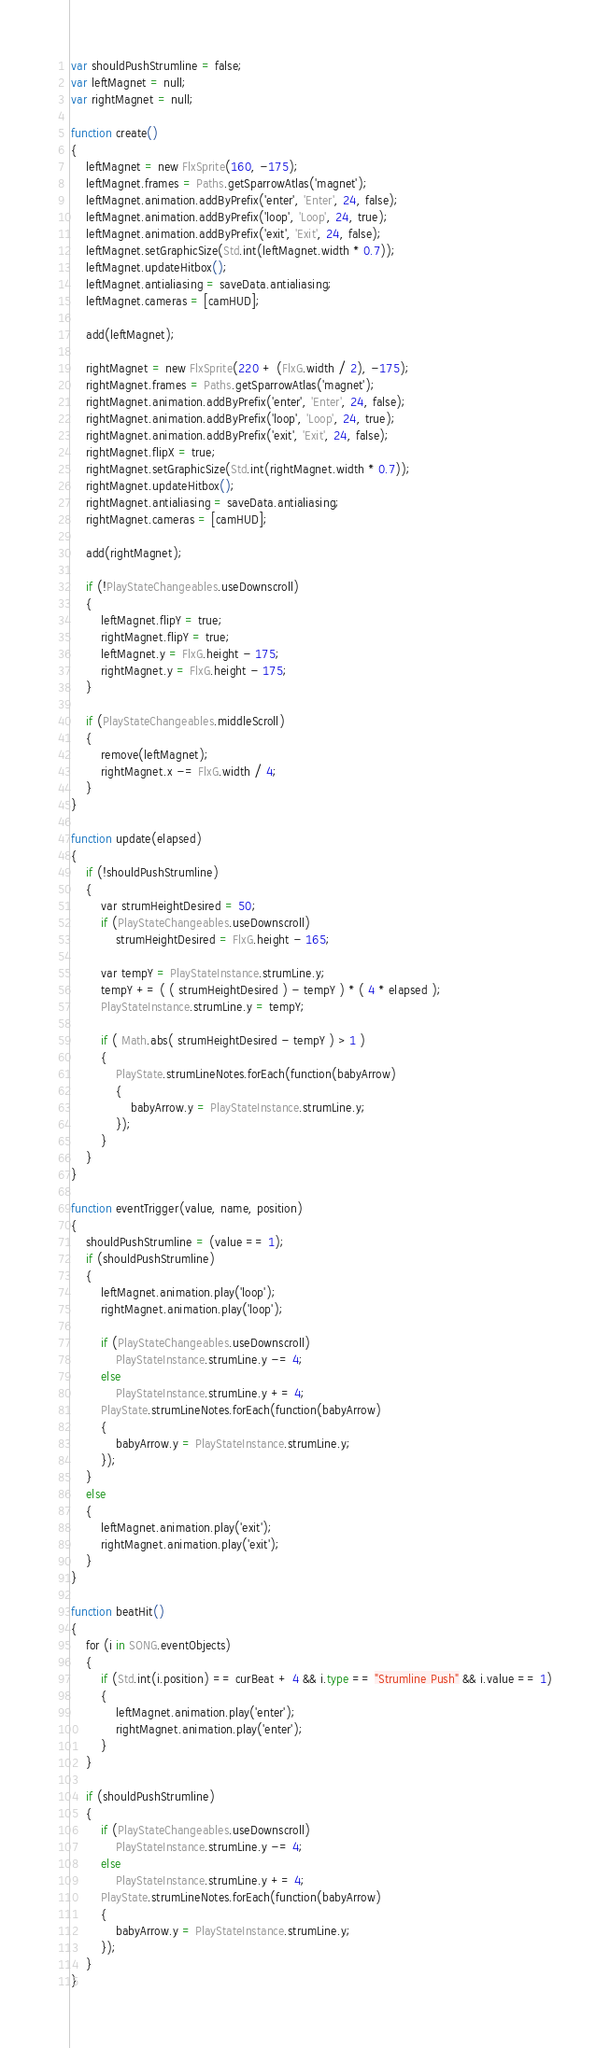Convert code to text. <code><loc_0><loc_0><loc_500><loc_500><_Haskell_>var shouldPushStrumline = false;
var leftMagnet = null;
var rightMagnet = null;

function create()
{
	leftMagnet = new FlxSprite(160, -175);
	leftMagnet.frames = Paths.getSparrowAtlas('magnet');
	leftMagnet.animation.addByPrefix('enter', 'Enter', 24, false);
	leftMagnet.animation.addByPrefix('loop', 'Loop', 24, true);
	leftMagnet.animation.addByPrefix('exit', 'Exit', 24, false);
	leftMagnet.setGraphicSize(Std.int(leftMagnet.width * 0.7));
	leftMagnet.updateHitbox();
	leftMagnet.antialiasing = saveData.antialiasing;
	leftMagnet.cameras = [camHUD];

	add(leftMagnet);

	rightMagnet = new FlxSprite(220 + (FlxG.width / 2), -175);
	rightMagnet.frames = Paths.getSparrowAtlas('magnet');
	rightMagnet.animation.addByPrefix('enter', 'Enter', 24, false);
	rightMagnet.animation.addByPrefix('loop', 'Loop', 24, true);
	rightMagnet.animation.addByPrefix('exit', 'Exit', 24, false);
	rightMagnet.flipX = true;
	rightMagnet.setGraphicSize(Std.int(rightMagnet.width * 0.7));
	rightMagnet.updateHitbox();
	rightMagnet.antialiasing = saveData.antialiasing;
	rightMagnet.cameras = [camHUD];

	add(rightMagnet);

	if (!PlayStateChangeables.useDownscroll)
	{
		leftMagnet.flipY = true;
		rightMagnet.flipY = true;
		leftMagnet.y = FlxG.height - 175;
		rightMagnet.y = FlxG.height - 175;
	}

	if (PlayStateChangeables.middleScroll)
	{
		remove(leftMagnet);
		rightMagnet.x -= FlxG.width / 4;
	}
}

function update(elapsed)
{
	if (!shouldPushStrumline)
	{
		var strumHeightDesired = 50;
		if (PlayStateChangeables.useDownscroll)
			strumHeightDesired = FlxG.height - 165;

		var tempY = PlayStateInstance.strumLine.y;
		tempY += ( ( strumHeightDesired ) - tempY ) * ( 4 * elapsed );
		PlayStateInstance.strumLine.y = tempY;

		if ( Math.abs( strumHeightDesired - tempY ) > 1 )
		{
			PlayState.strumLineNotes.forEach(function(babyArrow)
			{
				babyArrow.y = PlayStateInstance.strumLine.y;
			});
		}
	}
}

function eventTrigger(value, name, position)
{
	shouldPushStrumline = (value == 1);
	if (shouldPushStrumline)
	{
		leftMagnet.animation.play('loop');
		rightMagnet.animation.play('loop');

		if (PlayStateChangeables.useDownscroll)
			PlayStateInstance.strumLine.y -= 4;
		else
			PlayStateInstance.strumLine.y += 4;
		PlayState.strumLineNotes.forEach(function(babyArrow)
		{
			babyArrow.y = PlayStateInstance.strumLine.y;
		});
	}
	else
	{
		leftMagnet.animation.play('exit');
		rightMagnet.animation.play('exit');
	}
}

function beatHit()
{
	for (i in SONG.eventObjects)
	{
		if (Std.int(i.position) == curBeat + 4 && i.type == "Strumline Push" && i.value == 1)
		{
			leftMagnet.animation.play('enter');
			rightMagnet.animation.play('enter');
		}
	}

	if (shouldPushStrumline)
	{
		if (PlayStateChangeables.useDownscroll)
			PlayStateInstance.strumLine.y -= 4;
		else
			PlayStateInstance.strumLine.y += 4;
		PlayState.strumLineNotes.forEach(function(babyArrow)
		{
			babyArrow.y = PlayStateInstance.strumLine.y;
		});
	}
}</code> 